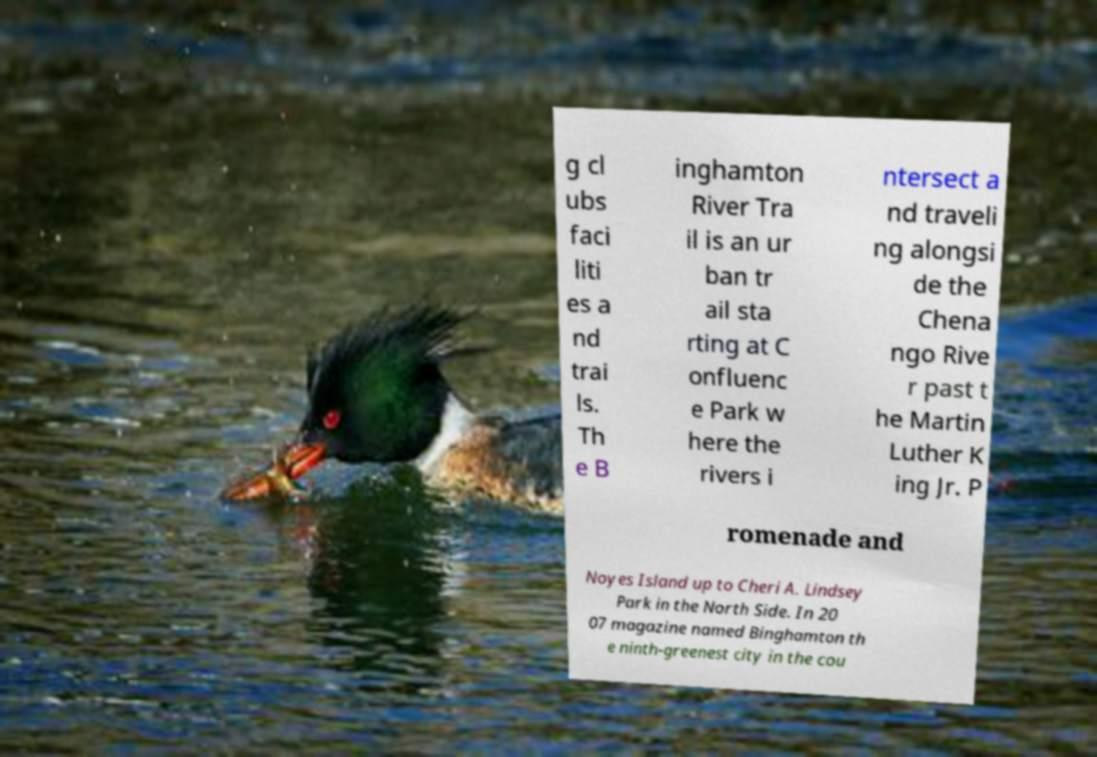Could you extract and type out the text from this image? g cl ubs faci liti es a nd trai ls. Th e B inghamton River Tra il is an ur ban tr ail sta rting at C onfluenc e Park w here the rivers i ntersect a nd traveli ng alongsi de the Chena ngo Rive r past t he Martin Luther K ing Jr. P romenade and Noyes Island up to Cheri A. Lindsey Park in the North Side. In 20 07 magazine named Binghamton th e ninth-greenest city in the cou 